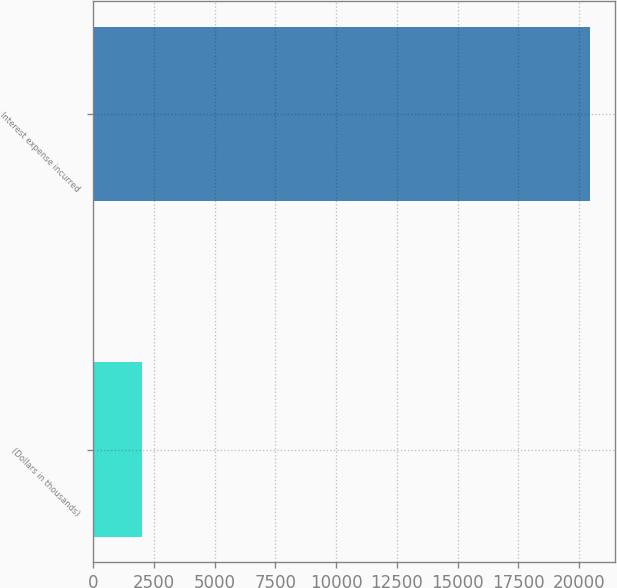Convert chart to OTSL. <chart><loc_0><loc_0><loc_500><loc_500><bar_chart><fcel>(Dollars in thousands)<fcel>Interest expense incurred<nl><fcel>2011<fcel>20454<nl></chart> 